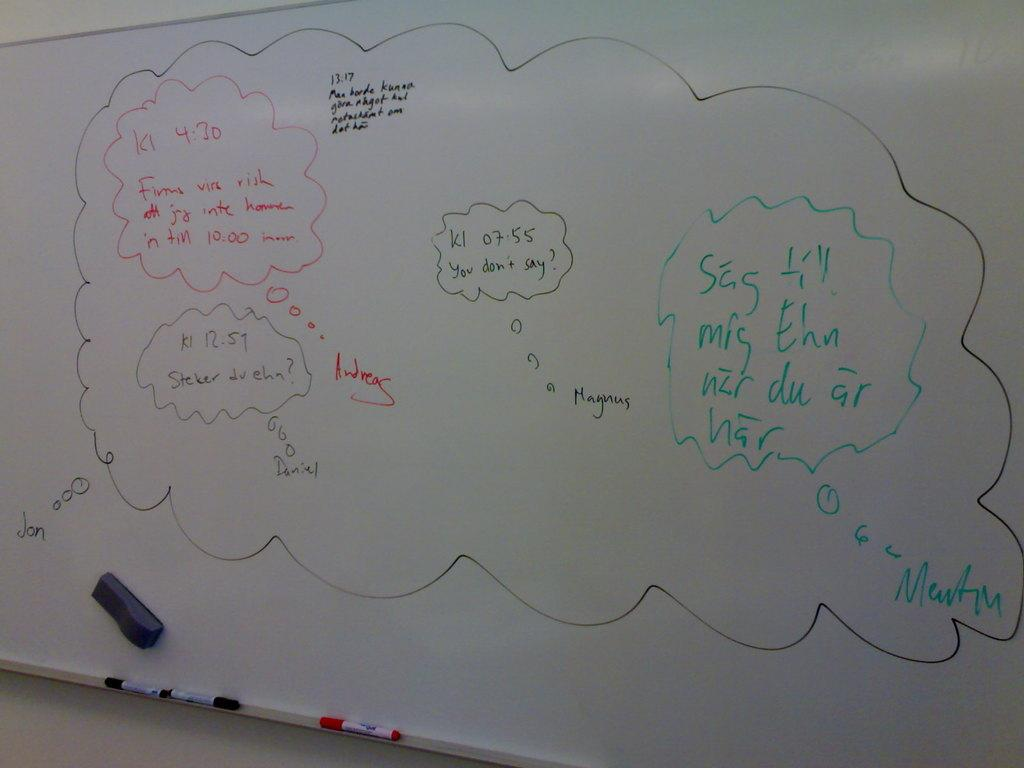<image>
Describe the image concisely. some problems on a board that include the word magnus 